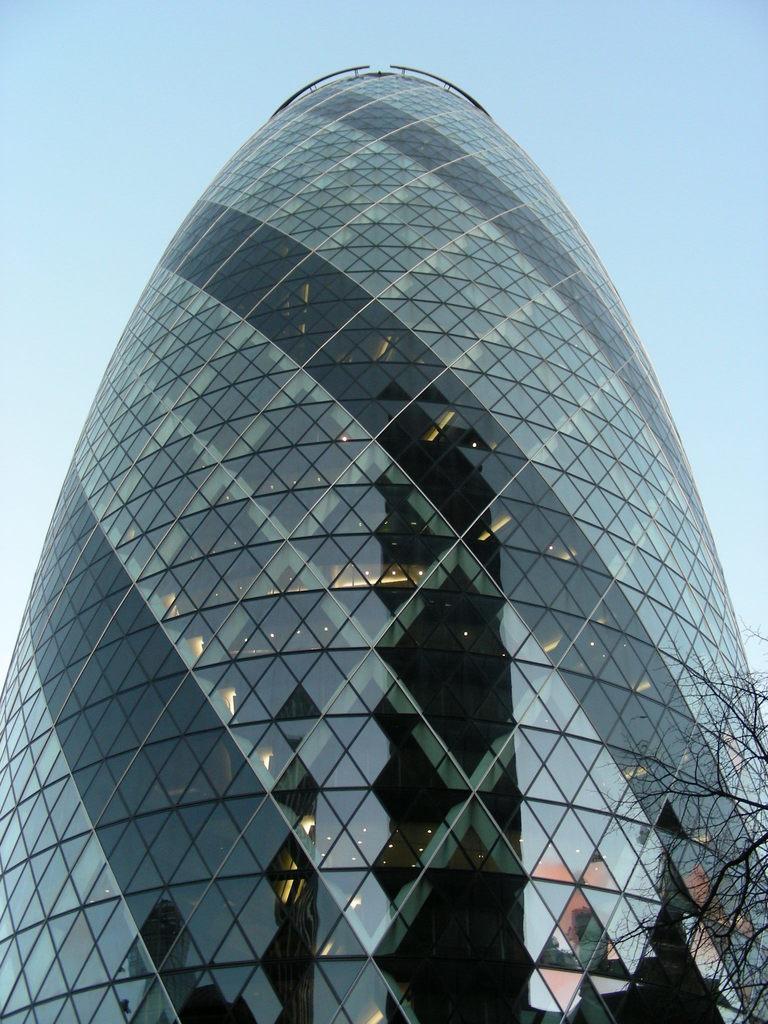Could you give a brief overview of what you see in this image? In this picture we can see an architecture building. On the right side of the image, there is a tree. Behind the building, there is the sky. 